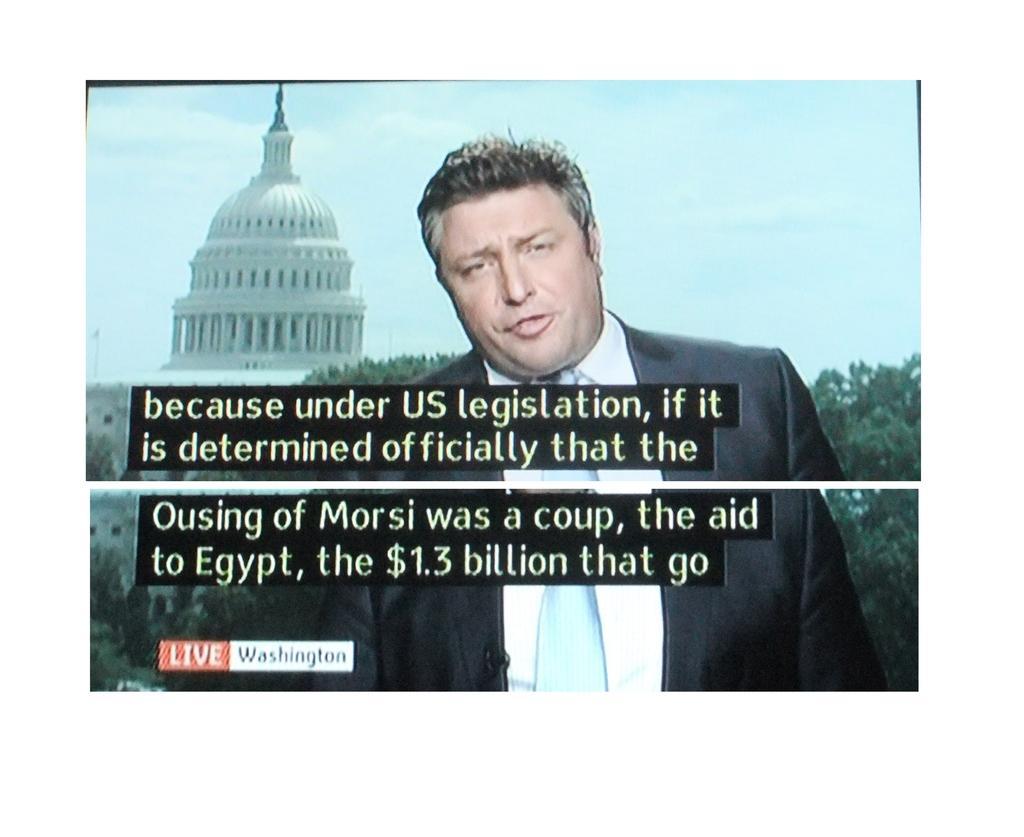In one or two sentences, can you explain what this image depicts? In this image I can see a person wearing black and white color dress. Back I can see white color fort and a trees The sky is in blue color. 